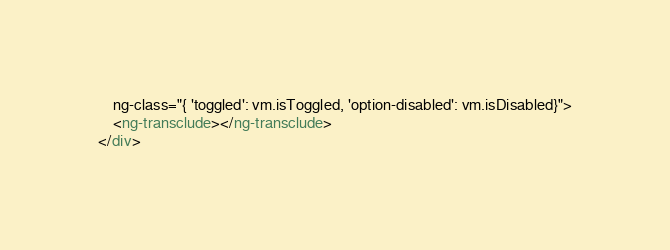<code> <loc_0><loc_0><loc_500><loc_500><_HTML_>    ng-class="{ 'toggled': vm.isToggled, 'option-disabled': vm.isDisabled}">
    <ng-transclude></ng-transclude>
</div></code> 